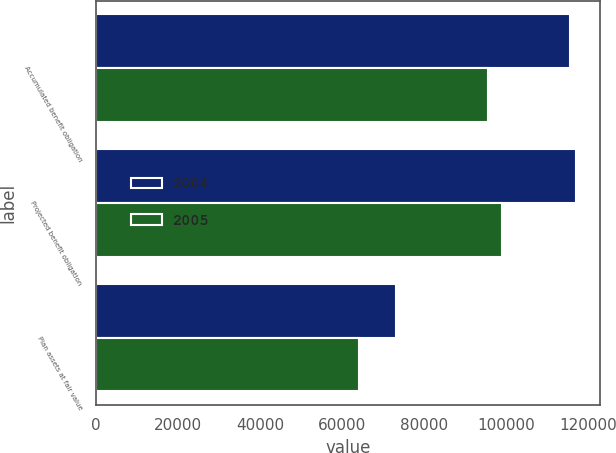Convert chart. <chart><loc_0><loc_0><loc_500><loc_500><stacked_bar_chart><ecel><fcel>Accumulated benefit obligation<fcel>Projected benefit obligation<fcel>Plan assets at fair value<nl><fcel>2004<fcel>115515<fcel>116992<fcel>73210<nl><fcel>2005<fcel>95624<fcel>98986<fcel>64210<nl></chart> 